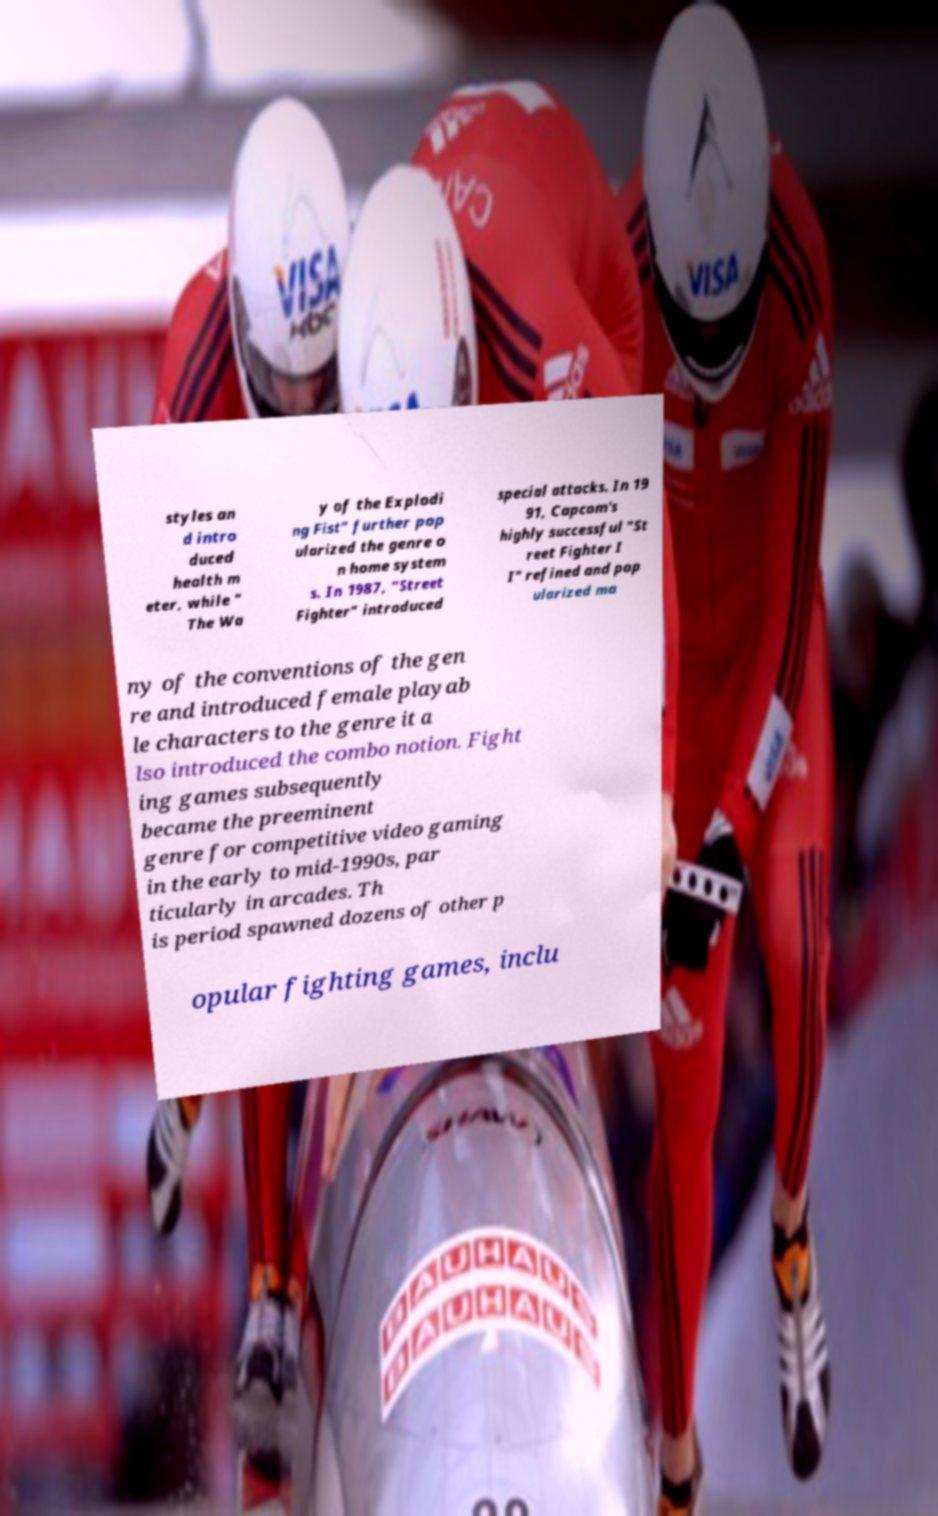Could you extract and type out the text from this image? styles an d intro duced health m eter, while " The Wa y of the Explodi ng Fist" further pop ularized the genre o n home system s. In 1987, "Street Fighter" introduced special attacks. In 19 91, Capcom's highly successful "St reet Fighter I I" refined and pop ularized ma ny of the conventions of the gen re and introduced female playab le characters to the genre it a lso introduced the combo notion. Fight ing games subsequently became the preeminent genre for competitive video gaming in the early to mid-1990s, par ticularly in arcades. Th is period spawned dozens of other p opular fighting games, inclu 